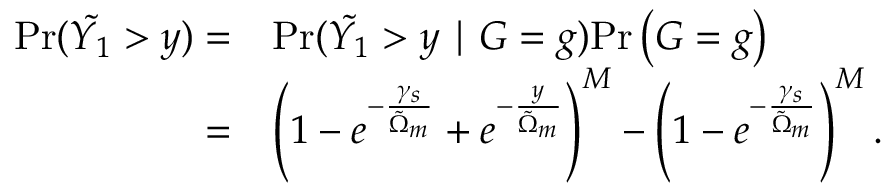Convert formula to latex. <formula><loc_0><loc_0><loc_500><loc_500>\begin{array} { r l } { P r ( \tilde { Y _ { 1 } } > y ) = } & { P r ( \tilde { Y _ { 1 } } > y | G = g ) P r \left ( G = g \right ) } \\ { = } & { \left ( 1 - e ^ { - \frac { \gamma _ { s } } { \tilde { \Omega } _ { m } } } + e ^ { - \frac { y } { \tilde { \Omega } _ { m } } } \right ) ^ { M } - \left ( 1 - e ^ { - \frac { \gamma _ { s } } { \tilde { \Omega } _ { m } } } \right ) ^ { M } . } \end{array}</formula> 